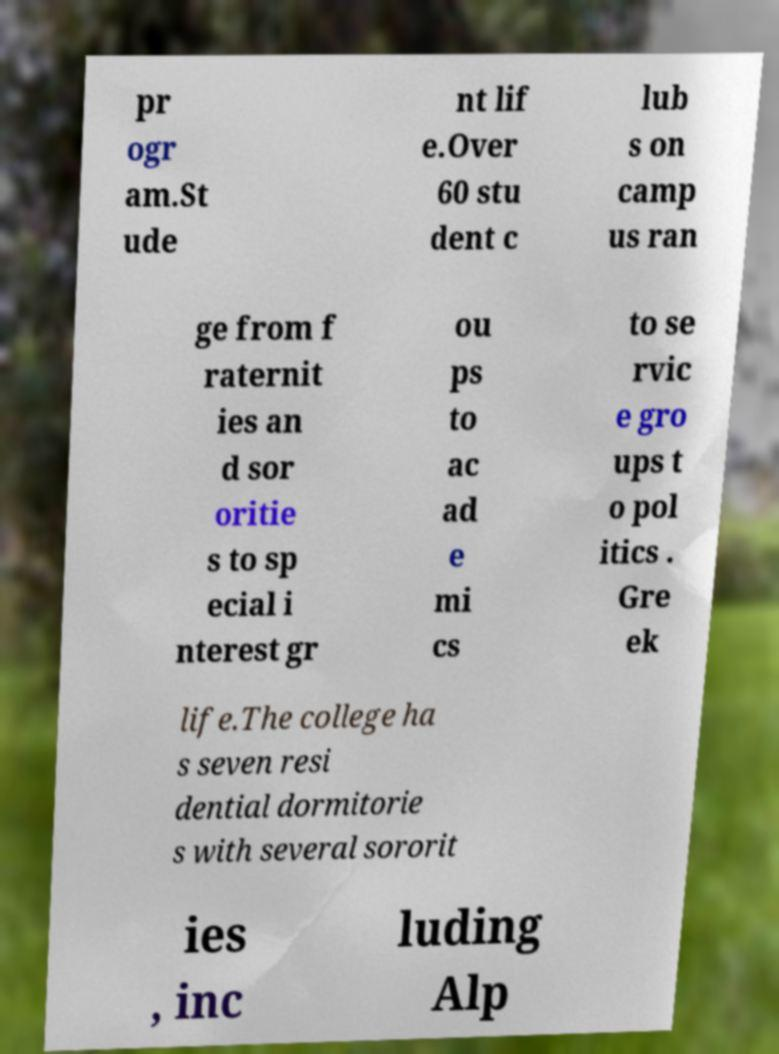What messages or text are displayed in this image? I need them in a readable, typed format. pr ogr am.St ude nt lif e.Over 60 stu dent c lub s on camp us ran ge from f raternit ies an d sor oritie s to sp ecial i nterest gr ou ps to ac ad e mi cs to se rvic e gro ups t o pol itics . Gre ek life.The college ha s seven resi dential dormitorie s with several sororit ies , inc luding Alp 